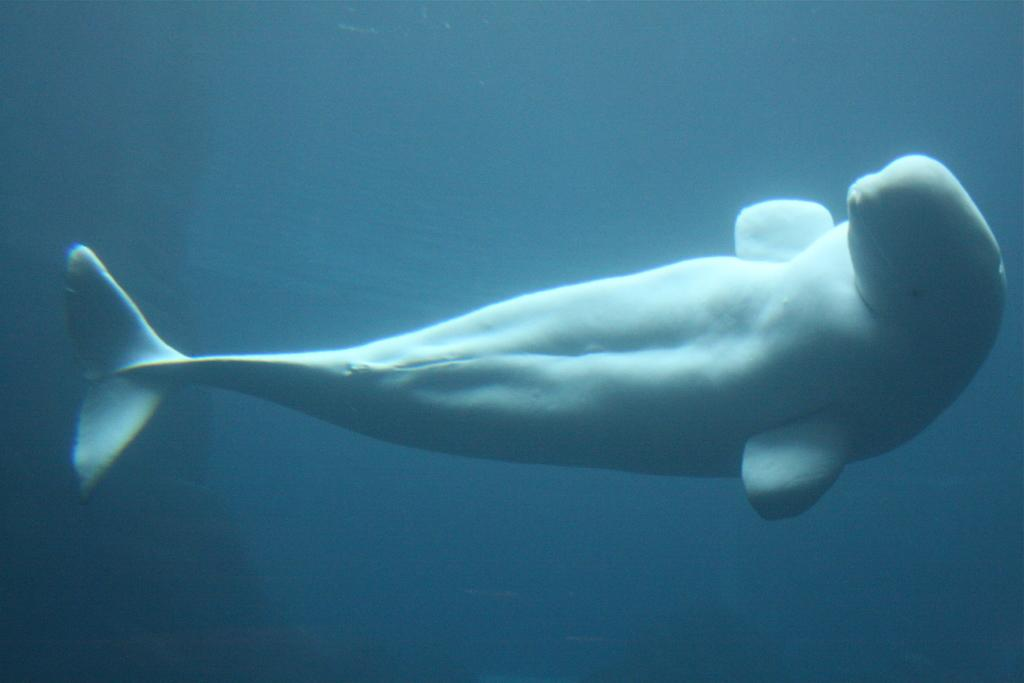What type of animal is in the image? There is a big fish in the image. Where is the fish located? The fish is in the water. What do the giants say to the fish in the image? There are no giants present in the image, so they cannot say anything to the fish. 